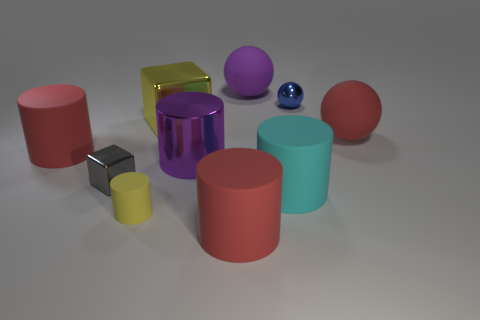There is a large rubber cylinder behind the tiny metal object that is left of the yellow rubber cylinder that is to the left of the blue sphere; what is its color?
Your answer should be very brief. Red. What number of rubber objects are either large red cylinders or cylinders?
Your response must be concise. 4. Is the number of cubes on the right side of the gray shiny cube greater than the number of tiny gray objects behind the tiny blue object?
Make the answer very short. Yes. What number of other objects are there of the same size as the cyan cylinder?
Keep it short and to the point. 6. What is the size of the red cylinder to the right of the small thing in front of the cyan object?
Provide a succinct answer. Large. What number of small objects are either purple shiny cylinders or metallic things?
Provide a short and direct response. 2. What is the size of the red rubber cylinder that is to the right of the yellow thing that is behind the big matte sphere that is in front of the small blue metallic sphere?
Give a very brief answer. Large. Is there anything else of the same color as the big metallic cylinder?
Offer a very short reply. Yes. There is a purple thing that is behind the red rubber object behind the big matte thing left of the big purple metal object; what is it made of?
Give a very brief answer. Rubber. Is the small blue thing the same shape as the purple matte object?
Provide a short and direct response. Yes. 